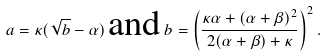Convert formula to latex. <formula><loc_0><loc_0><loc_500><loc_500>a = \kappa ( \sqrt { b } - \alpha ) \, \text {and} \, b = \left ( \frac { \kappa \alpha + ( \alpha + \beta ) ^ { 2 } } { 2 ( \alpha + \beta ) + \kappa } \right ) ^ { 2 } .</formula> 